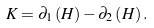<formula> <loc_0><loc_0><loc_500><loc_500>K = \partial _ { 1 } \left ( H \right ) - \partial _ { 2 } \left ( H \right ) .</formula> 